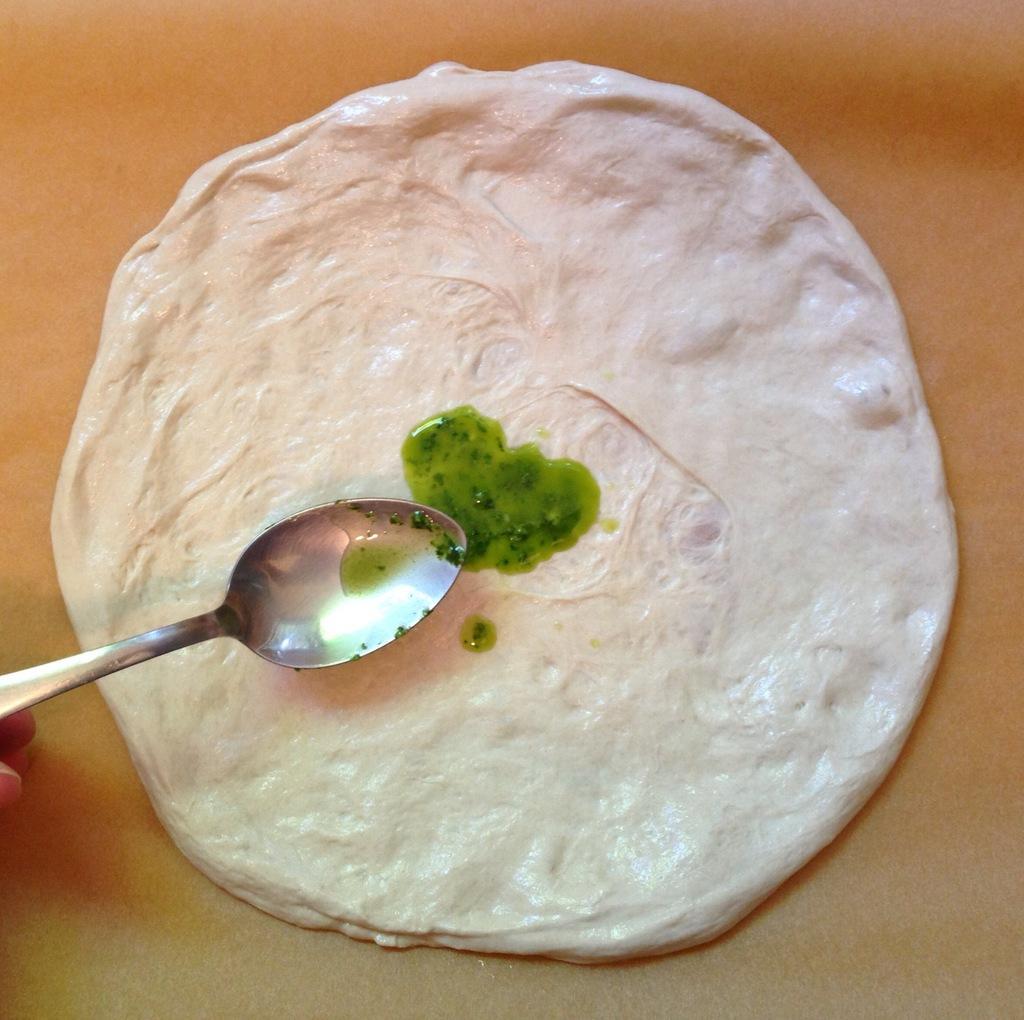Please provide a concise description of this image. In this picture I can see there is some food placed on the yellow surface and there is some green thing put on the food by the spoon. 